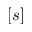Convert formula to latex. <formula><loc_0><loc_0><loc_500><loc_500>[ s ]</formula> 